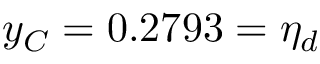Convert formula to latex. <formula><loc_0><loc_0><loc_500><loc_500>y _ { C } = 0 . 2 7 9 3 = \eta _ { d }</formula> 